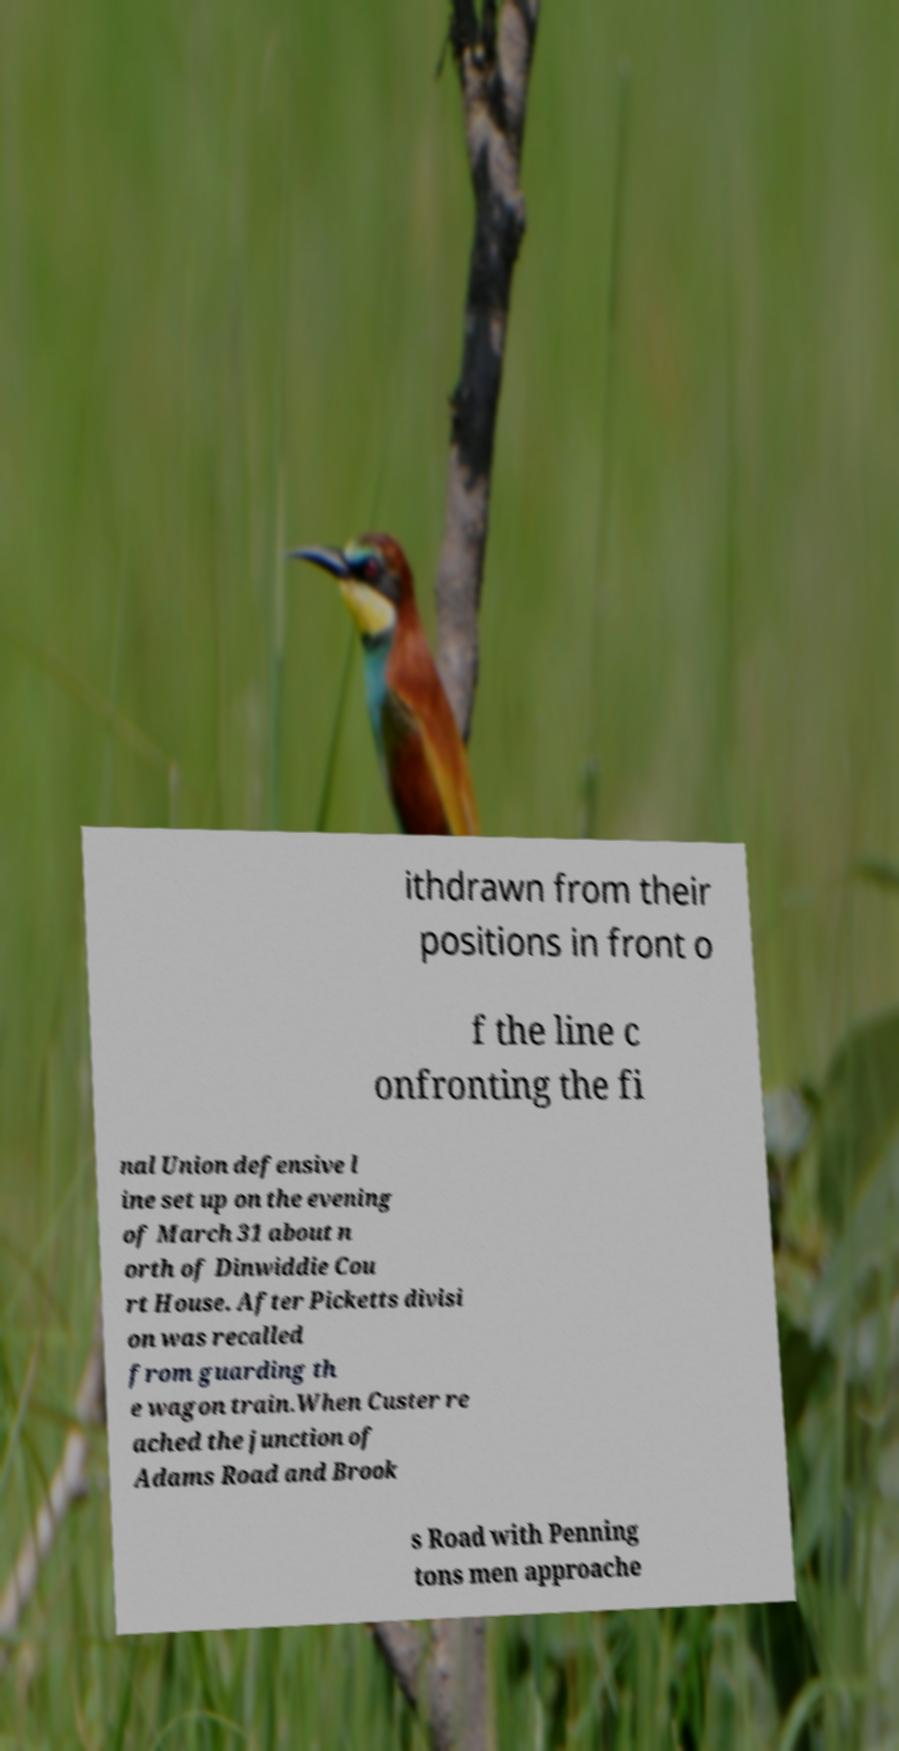Please identify and transcribe the text found in this image. ithdrawn from their positions in front o f the line c onfronting the fi nal Union defensive l ine set up on the evening of March 31 about n orth of Dinwiddie Cou rt House. After Picketts divisi on was recalled from guarding th e wagon train.When Custer re ached the junction of Adams Road and Brook s Road with Penning tons men approache 